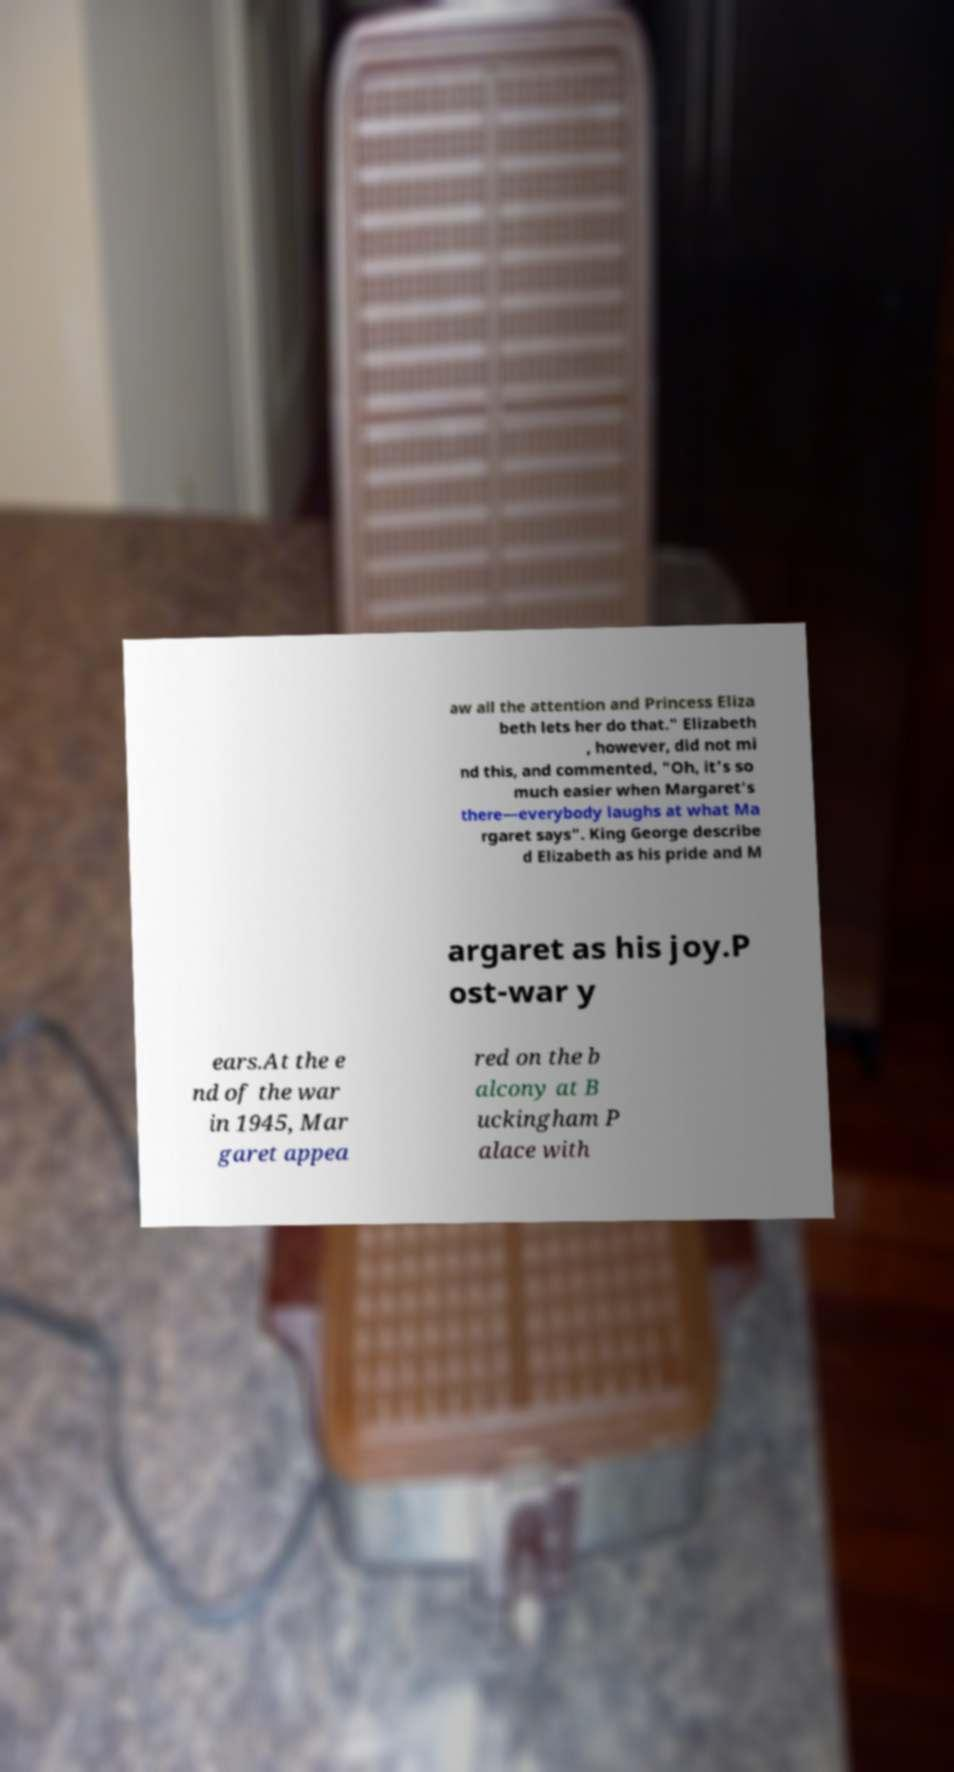Can you read and provide the text displayed in the image?This photo seems to have some interesting text. Can you extract and type it out for me? aw all the attention and Princess Eliza beth lets her do that." Elizabeth , however, did not mi nd this, and commented, "Oh, it's so much easier when Margaret's there—everybody laughs at what Ma rgaret says". King George describe d Elizabeth as his pride and M argaret as his joy.P ost-war y ears.At the e nd of the war in 1945, Mar garet appea red on the b alcony at B uckingham P alace with 